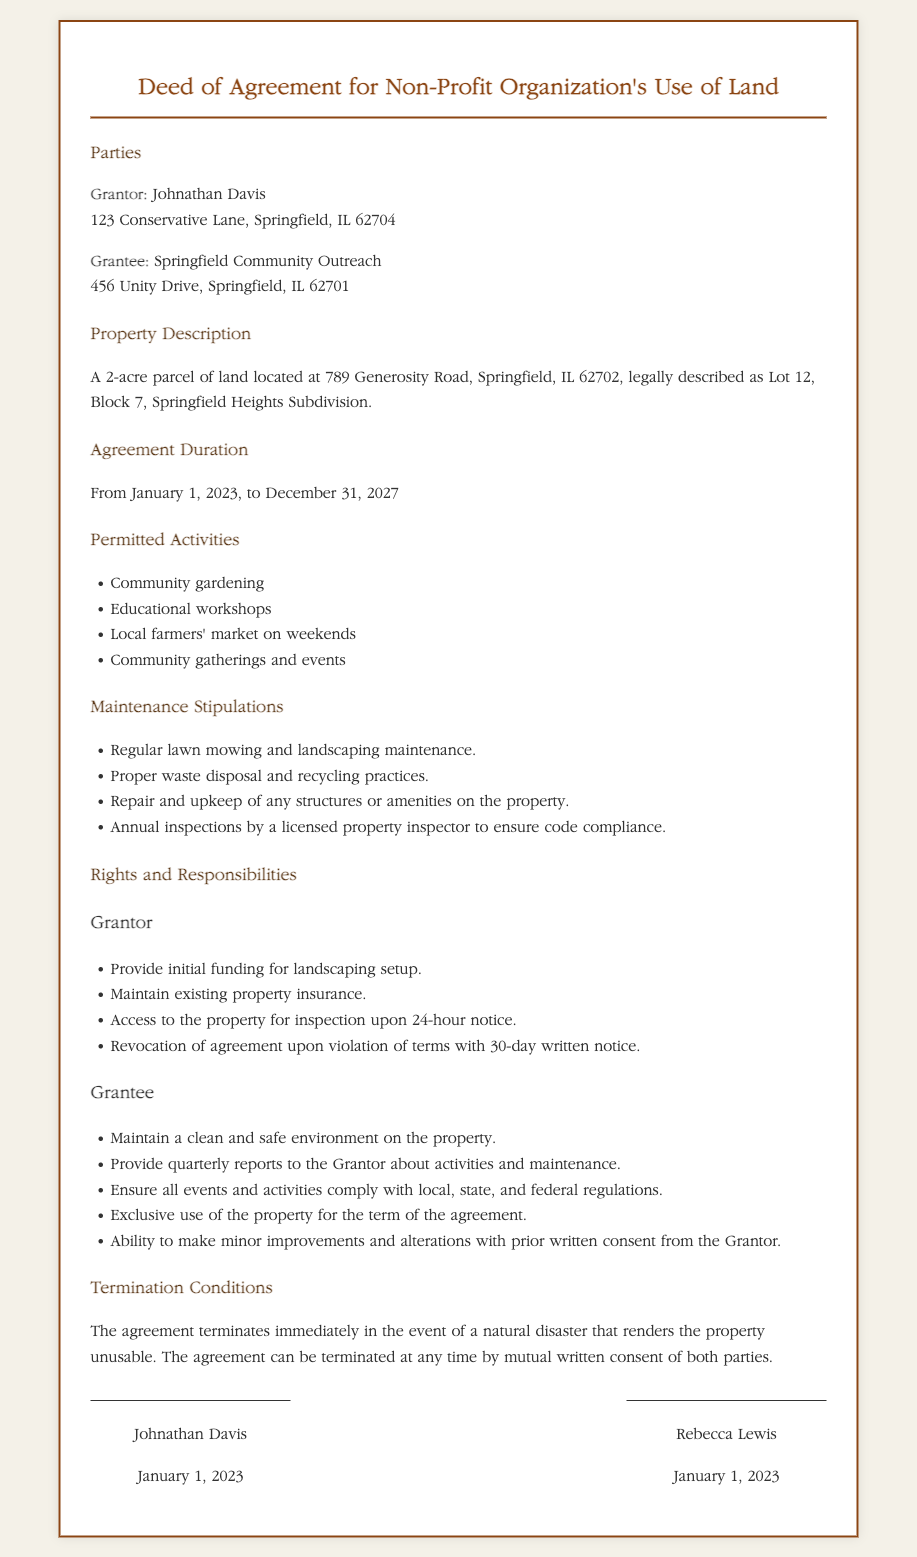What is the duration of the agreement? The duration of the agreement is specified in the document as running from January 1, 2023, to December 31, 2027.
Answer: From January 1, 2023, to December 31, 2027 Who is the grantor? The grantor is the individual or entity granting the use of the land, which is specified in the document.
Answer: Johnathan Davis What is the address of the grantee? The address provided for the grantee is included in the document.
Answer: 456 Unity Drive, Springfield, IL 62701 What type of activities are permitted? The document lists specific permitted activities, which provide insight into the use of the land.
Answer: Community gardening, Educational workshops, Local farmers' market on weekends, Community gatherings and events What must the grantor maintain regarding the property? The responsibilities of the grantor include specific obligations related to property maintenance outlined in the document.
Answer: Existing property insurance What conditions can lead to termination of the agreement? The document specifies the conditions under which the agreement may be terminated, requiring an understanding of the terms.
Answer: Natural disaster What is required from the grantee regarding the environment? The responsibilities of the grantee concerning the property's condition are outlined in the document.
Answer: Maintain a clean and safe environment on the property How long before inspection must the grantor notify? The document details the notice period required by the grantor before accessing the property for inspection.
Answer: 24-hour notice What is the location of the property? The specific location of the property is described in the document, which is crucial for understanding the agreement's context.
Answer: 789 Generosity Road, Springfield, IL 62702 